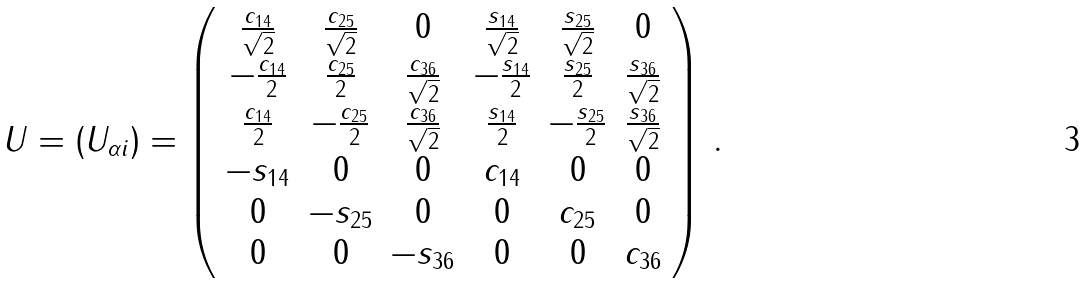Convert formula to latex. <formula><loc_0><loc_0><loc_500><loc_500>U = \left ( U _ { \alpha i } \right ) = \left ( \begin{array} { c c c c c c } \frac { c _ { 1 4 } } { \sqrt { 2 } } & \frac { c _ { 2 5 } } { \sqrt { 2 } } & 0 & \frac { s _ { 1 4 } } { \sqrt { 2 } } & \frac { s _ { 2 5 } } { \sqrt { 2 } } & 0 \\ - \frac { c _ { 1 4 } } { 2 } & \frac { c _ { 2 5 } } { 2 } & \frac { c _ { 3 6 } } { \sqrt { 2 } } & - \frac { s _ { 1 4 } } { 2 } & \frac { s _ { 2 5 } } { 2 } & \frac { s _ { 3 6 } } { \sqrt { 2 } } \\ \frac { c _ { 1 4 } } { 2 } & - \frac { c _ { 2 5 } } { 2 } & \frac { c _ { 3 6 } } { \sqrt { 2 } } & \frac { s _ { 1 4 } } { 2 } & - \frac { s _ { 2 5 } } { 2 } & \frac { s _ { 3 6 } } { \sqrt { 2 } } \\ - s _ { 1 4 } & 0 & 0 & c _ { 1 4 } & 0 & 0 \\ 0 & - s _ { 2 5 } & 0 & 0 & c _ { 2 5 } & 0 \\ 0 & 0 & - s _ { 3 6 } & 0 & 0 & c _ { 3 6 } \end{array} \right ) \, .</formula> 